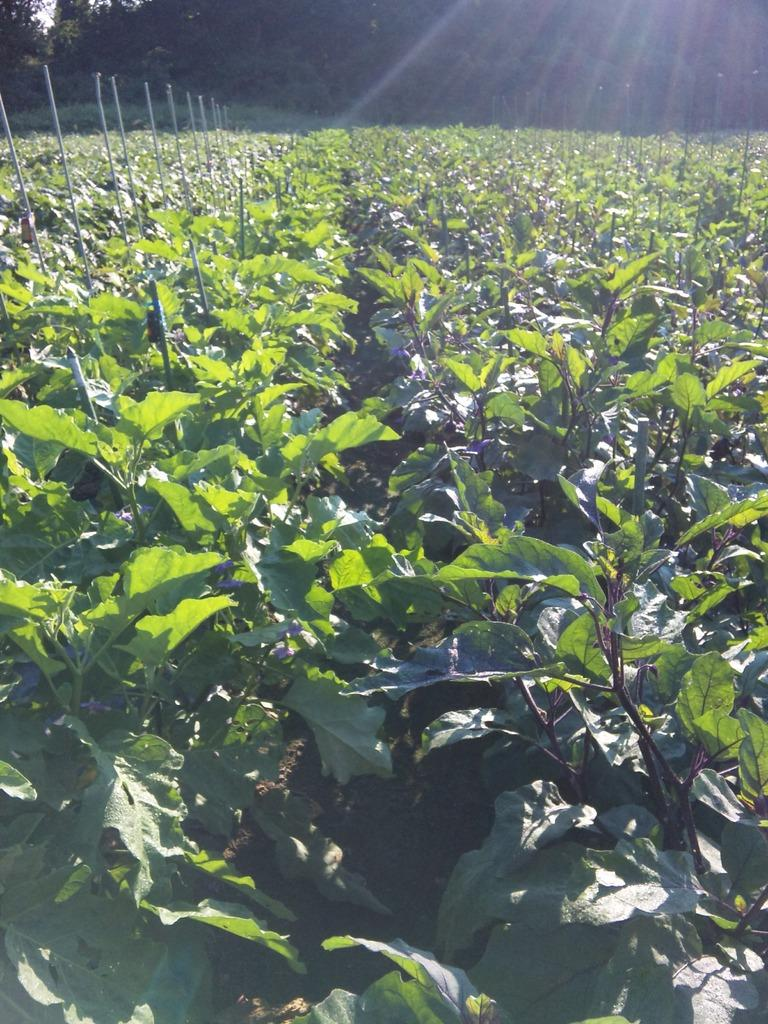What type of living organisms can be seen in the image? Plants can be seen in the image. What structures are present in the image? There are poles in the image. What can be seen in the background of the image? There are trees visible in the background of the image. How many chickens are sitting in the crib in the image? There are no chickens or cribs present in the image. 